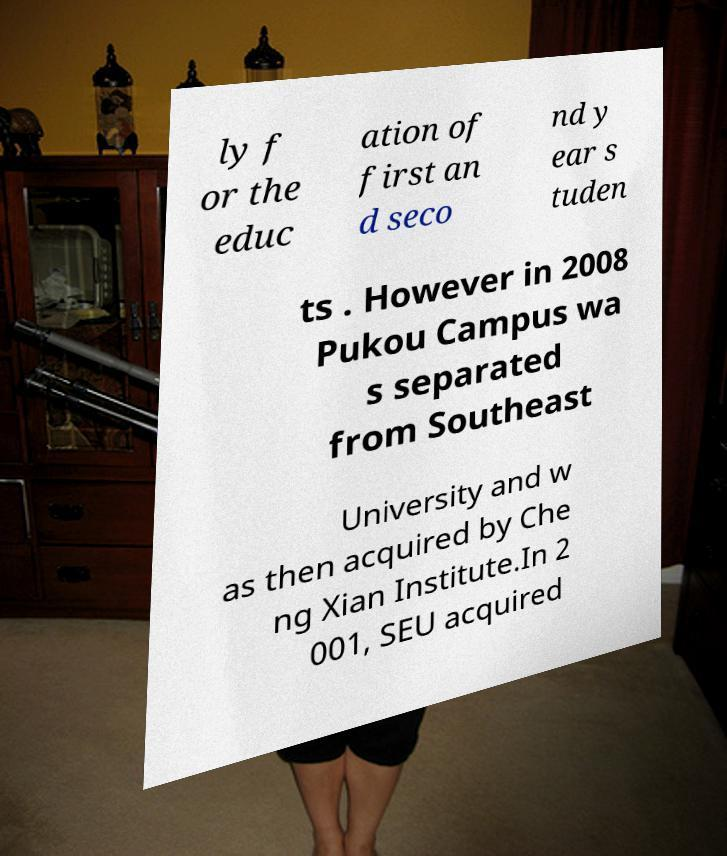There's text embedded in this image that I need extracted. Can you transcribe it verbatim? ly f or the educ ation of first an d seco nd y ear s tuden ts . However in 2008 Pukou Campus wa s separated from Southeast University and w as then acquired by Che ng Xian Institute.In 2 001, SEU acquired 